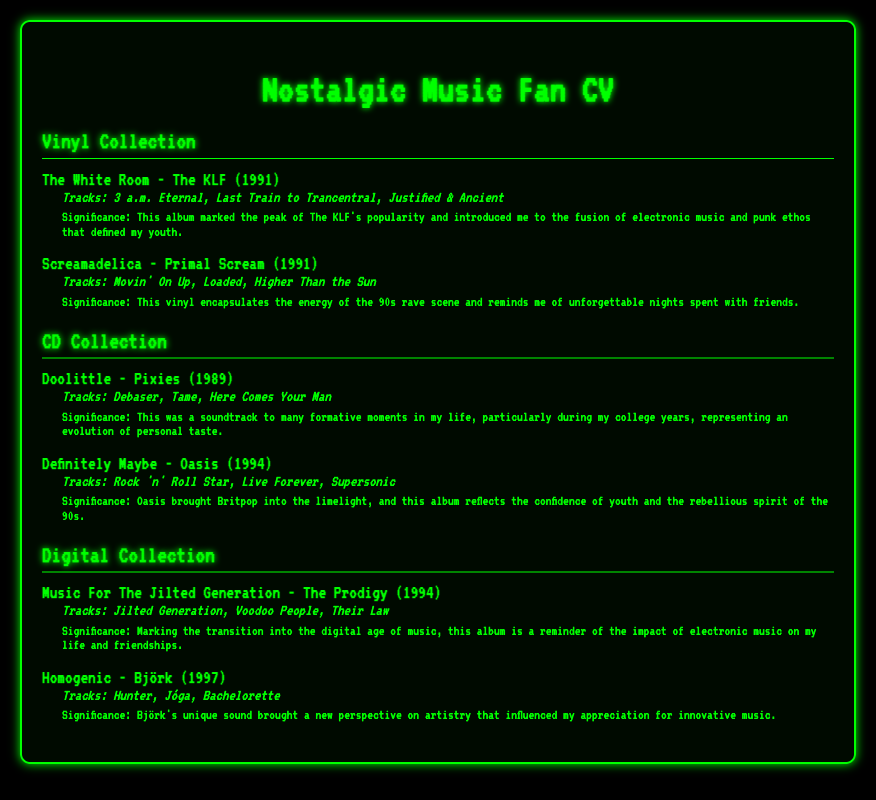What is the title of The KLF's album? The document lists "The White Room" as the title of The KLF's album.
Answer: The White Room How many tracks are on the album "Screamadelica"? The document states that the album "Screamadelica" has three tracks.
Answer: 3 What year was "Doolittle" by Pixies released? The document indicates that "Doolittle" was released in 1989.
Answer: 1989 Which album reflects the "confidence of youth"? According to the document, "Definitely Maybe" by Oasis reflects the confidence of youth.
Answer: Definitely Maybe Which album is noted for reminding the owner of unforgettable nights? "Screamadelica" is mentioned as reminding the owner of unforgettable nights.
Answer: Screamadelica What type of music transitioned during "Music For The Jilted Generation"? The document suggests that this album marks the transition into the digital age of music.
Answer: Digital age What genre does the album "Homogenic" represent? The document describes Björk's album "Homogenic" as innovative music.
Answer: Innovative music How many albums are listed in the Vinyl Collection? The document lists two albums in the Vinyl Collection.
Answer: 2 Which band is associated with the track "3 a.m. Eternal"? The document states that "3 a.m. Eternal" is by The KLF.
Answer: The KLF 